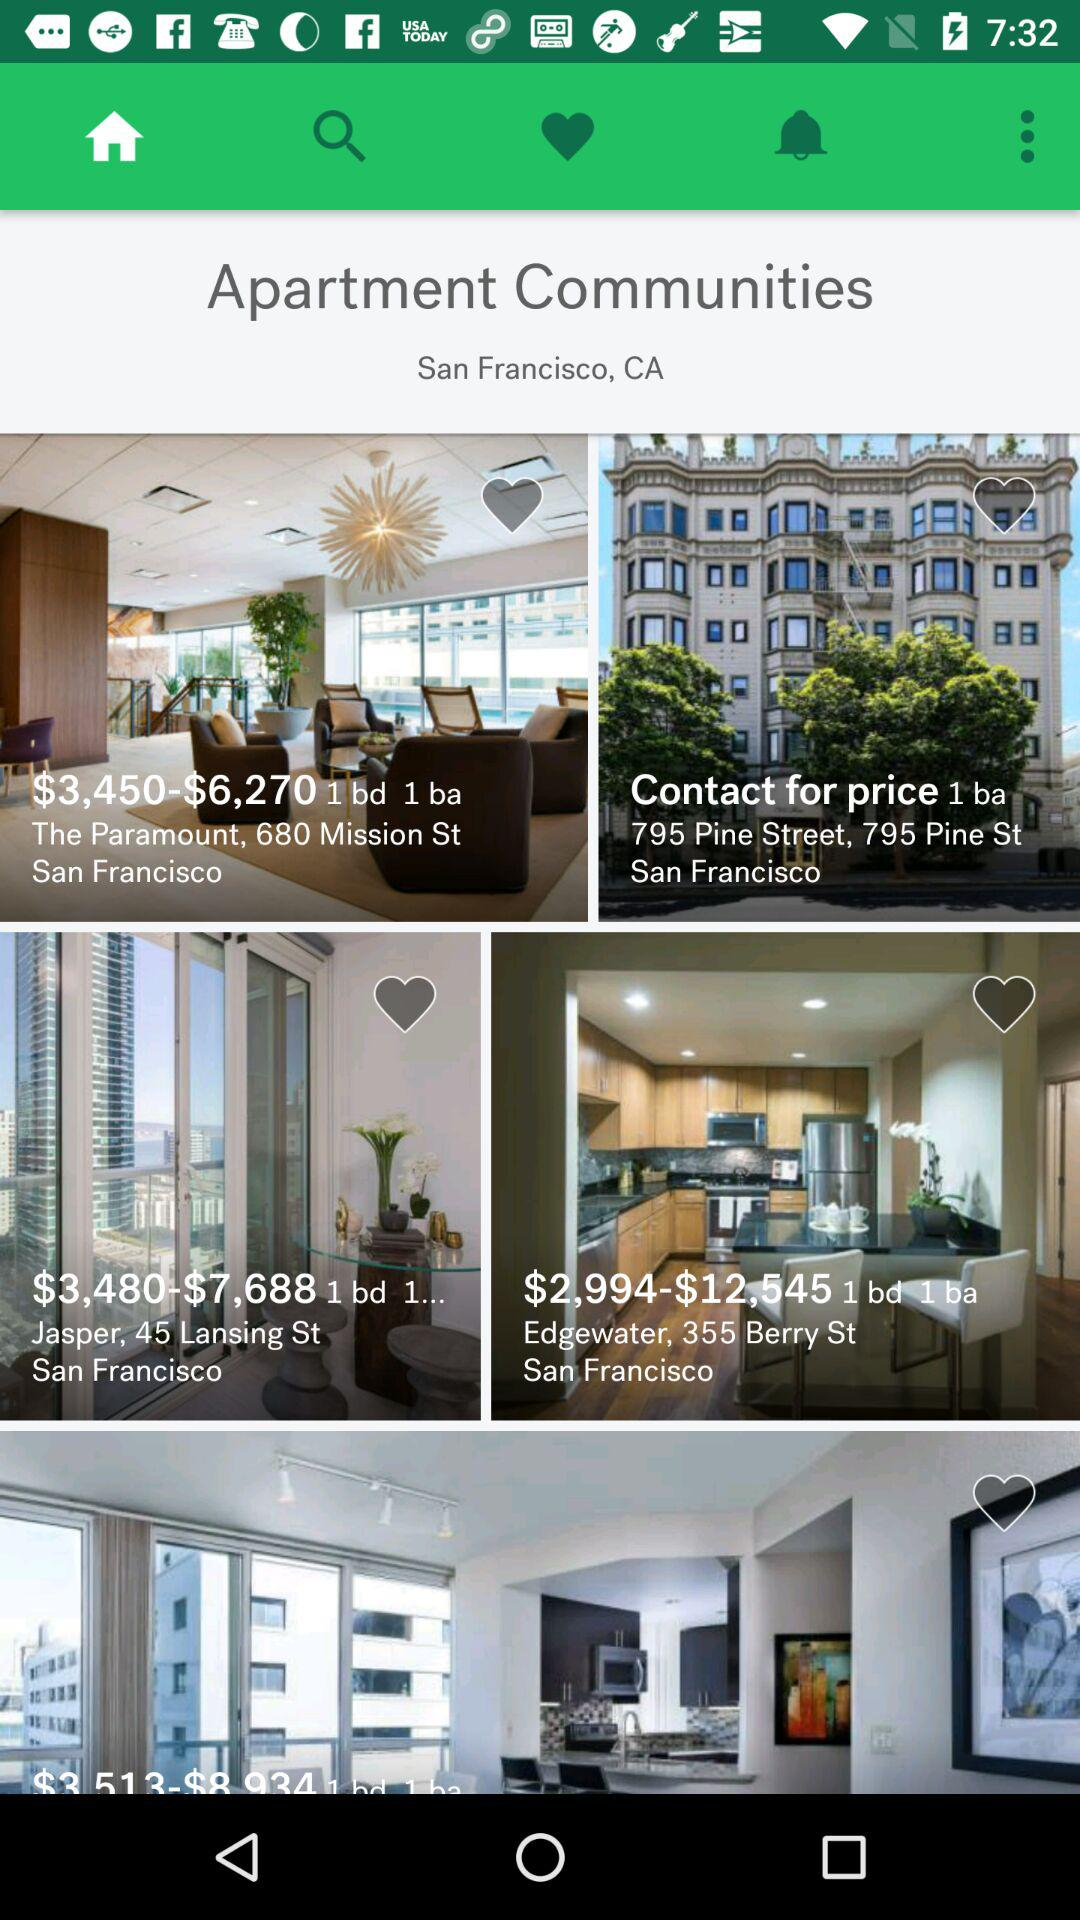How many bedrooms and bathrooms are available in the "Edgewater" at 355 Berry St.? There is 1 bedroom and 1 bathroom available in the "Edgewater" at 355 Berry St. 